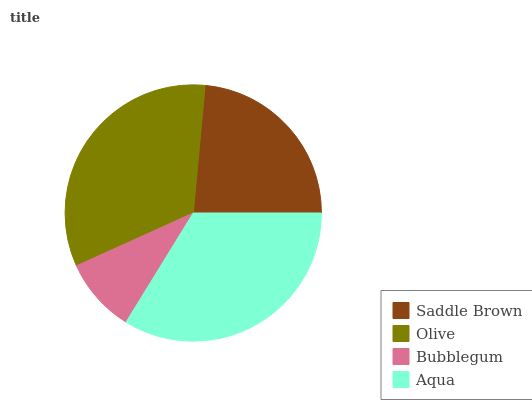Is Bubblegum the minimum?
Answer yes or no. Yes. Is Aqua the maximum?
Answer yes or no. Yes. Is Olive the minimum?
Answer yes or no. No. Is Olive the maximum?
Answer yes or no. No. Is Olive greater than Saddle Brown?
Answer yes or no. Yes. Is Saddle Brown less than Olive?
Answer yes or no. Yes. Is Saddle Brown greater than Olive?
Answer yes or no. No. Is Olive less than Saddle Brown?
Answer yes or no. No. Is Olive the high median?
Answer yes or no. Yes. Is Saddle Brown the low median?
Answer yes or no. Yes. Is Bubblegum the high median?
Answer yes or no. No. Is Aqua the low median?
Answer yes or no. No. 